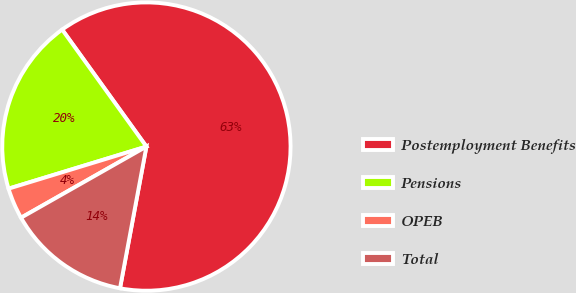Convert chart to OTSL. <chart><loc_0><loc_0><loc_500><loc_500><pie_chart><fcel>Postemployment Benefits<fcel>Pensions<fcel>OPEB<fcel>Total<nl><fcel>62.87%<fcel>19.78%<fcel>3.5%<fcel>13.85%<nl></chart> 